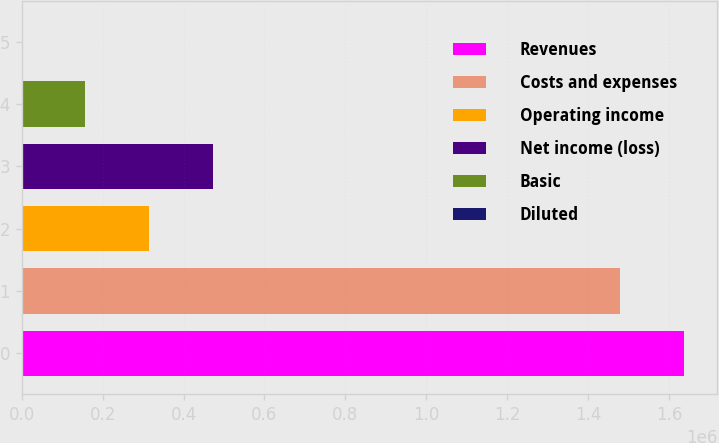<chart> <loc_0><loc_0><loc_500><loc_500><bar_chart><fcel>Revenues<fcel>Costs and expenses<fcel>Operating income<fcel>Net income (loss)<fcel>Basic<fcel>Diluted<nl><fcel>1.63695e+06<fcel>1.47943e+06<fcel>315051<fcel>472576<fcel>157526<fcel>1.53<nl></chart> 